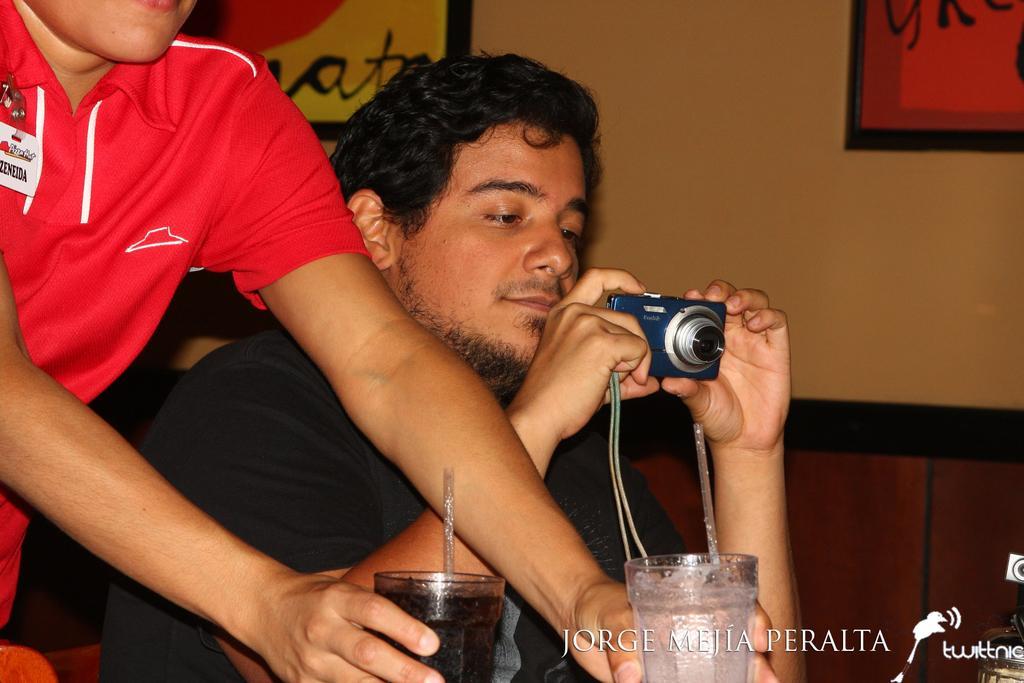Describe this image in one or two sentences. In this image I can see a man is holding a camera. I can also see another person is holding two glasses. 